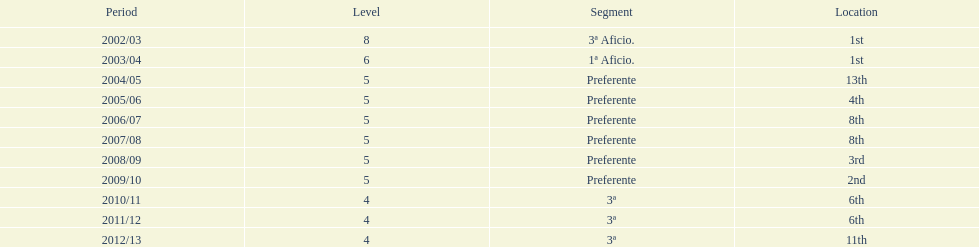What was the number of wins for preferente? 6. 